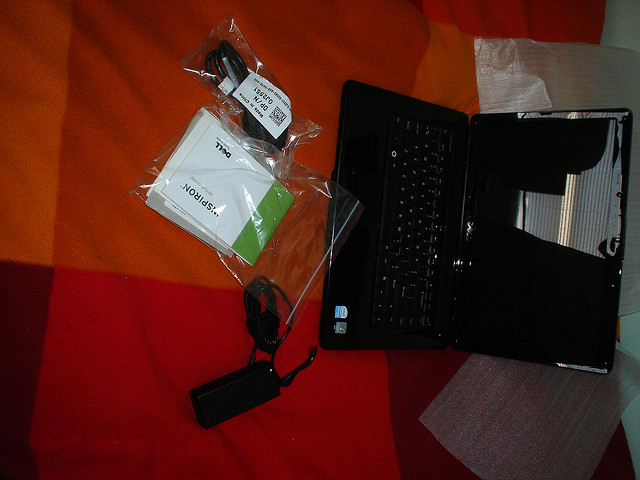<image>What is the picture on the book? There is no picture on the book. What is the picture on the book? There is no picture on the book. 